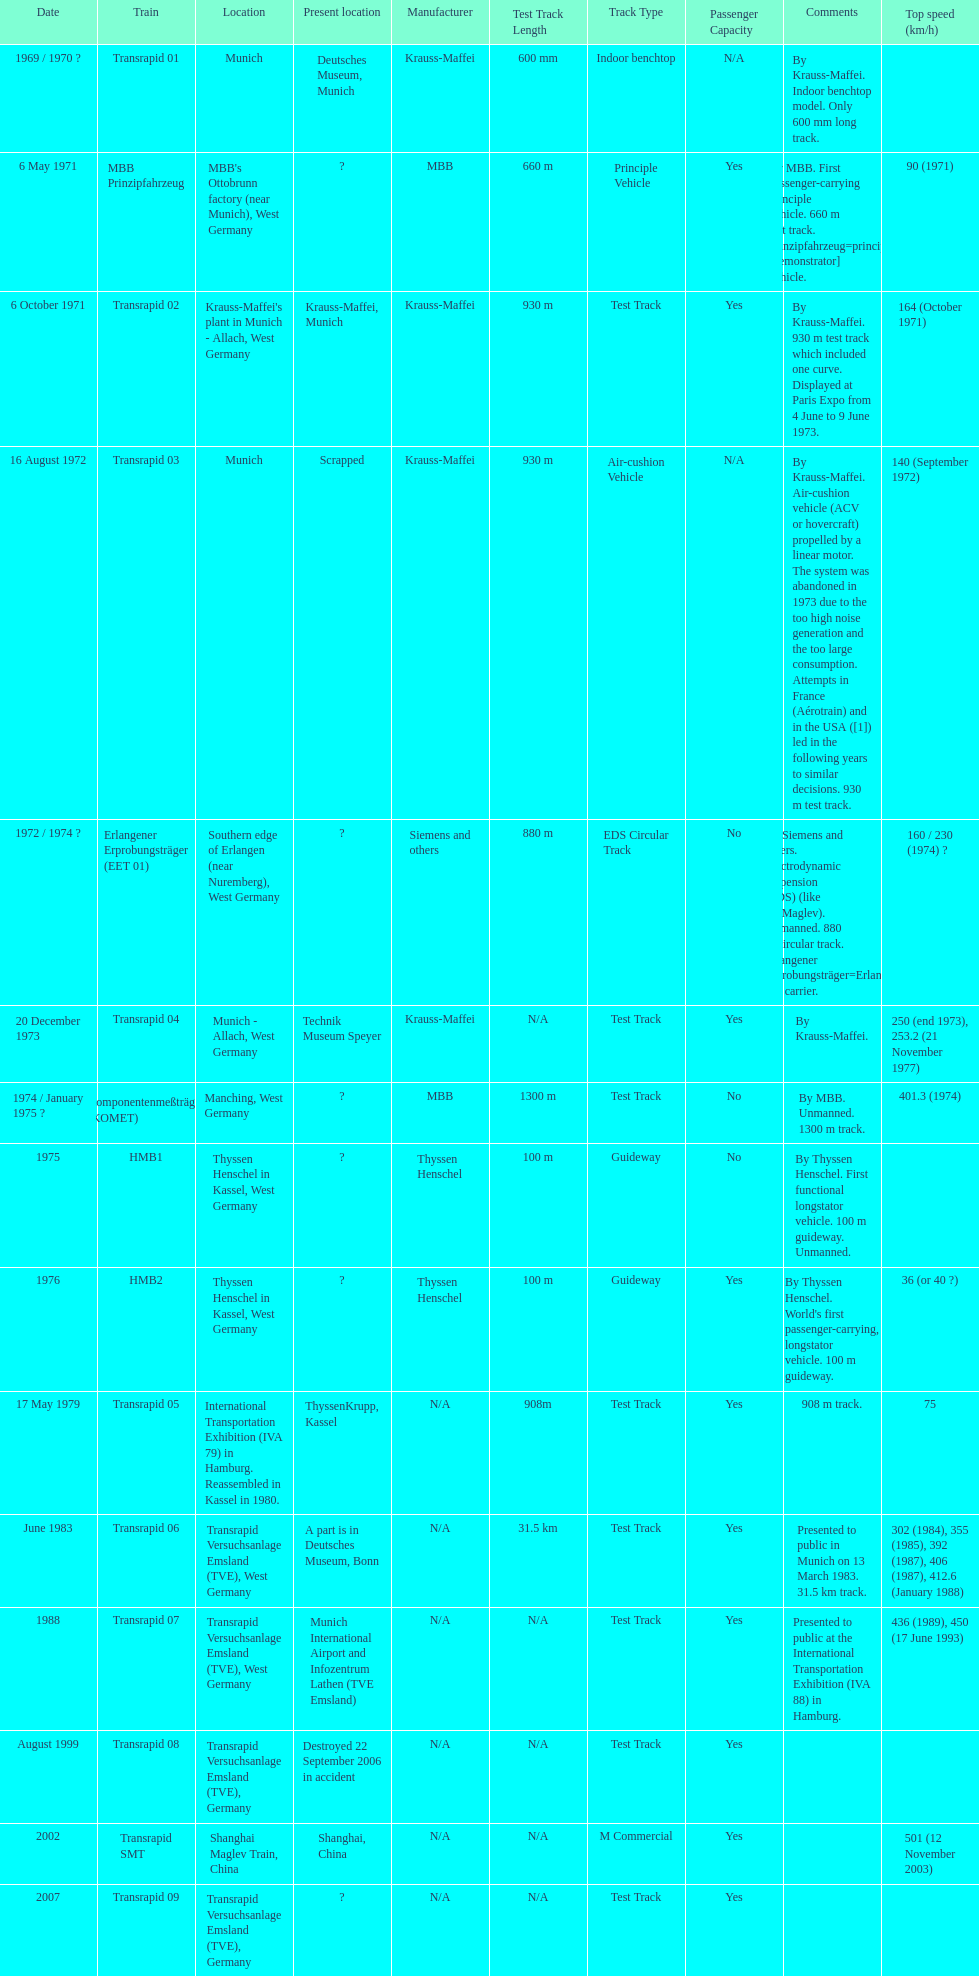What is the count of versions that have been discarded? 1. 